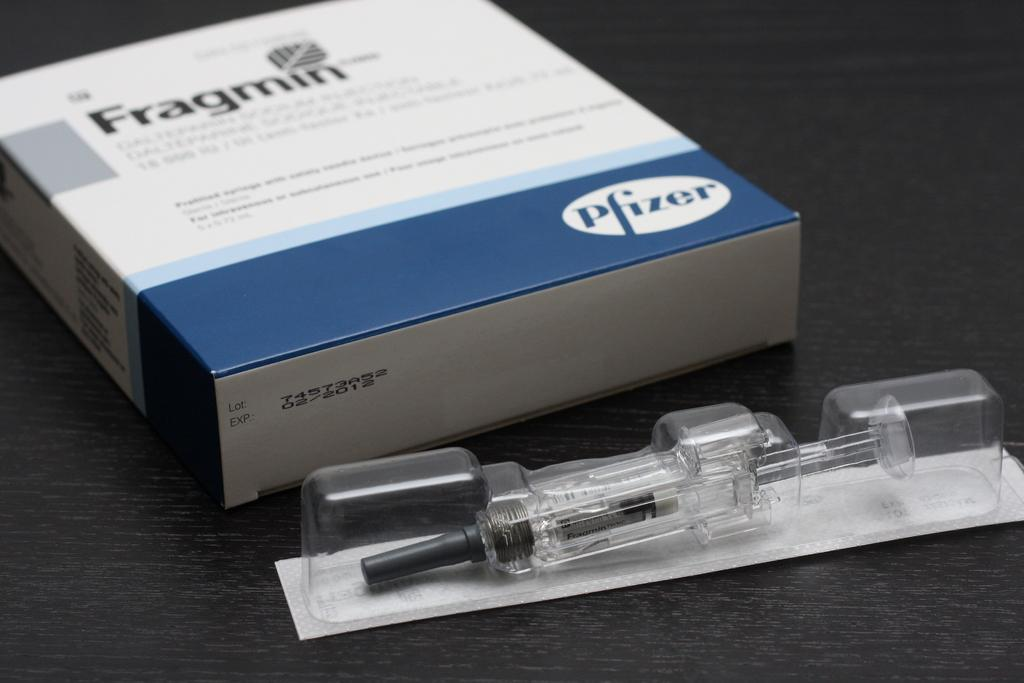<image>
Render a clear and concise summary of the photo. A box of Fragmin and an unused syringe on a table. 